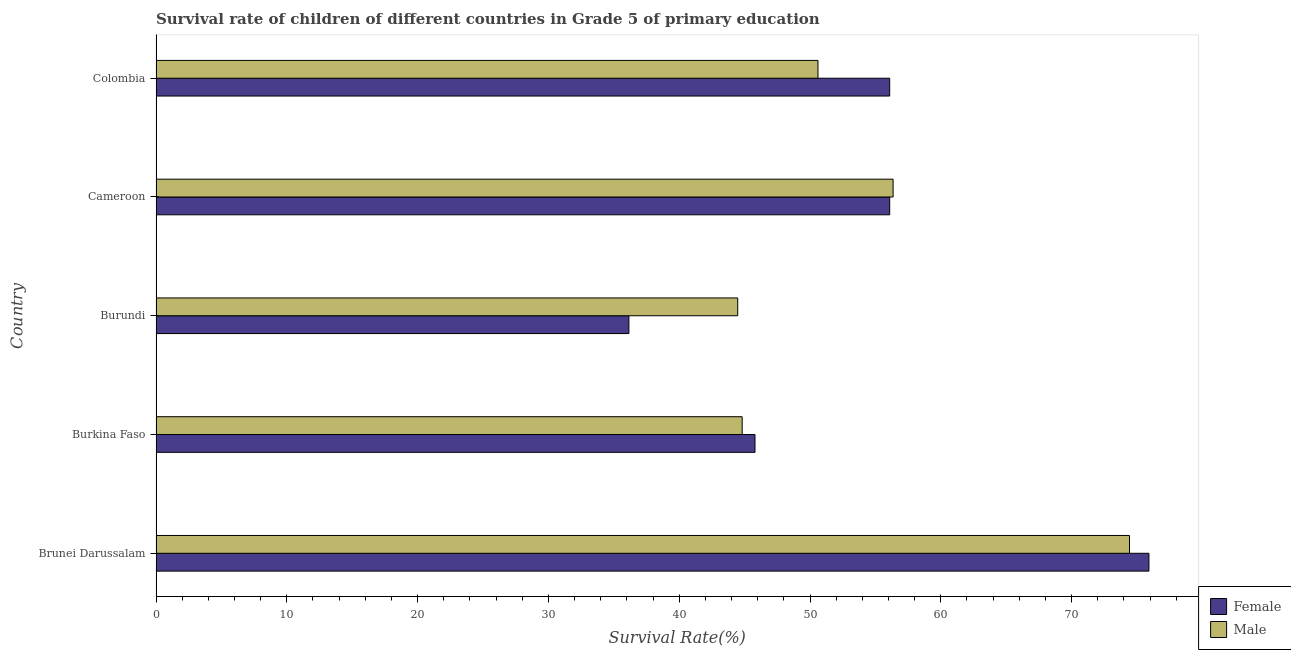Are the number of bars on each tick of the Y-axis equal?
Provide a succinct answer. Yes. What is the label of the 5th group of bars from the top?
Your response must be concise. Brunei Darussalam. What is the survival rate of male students in primary education in Brunei Darussalam?
Offer a very short reply. 74.42. Across all countries, what is the maximum survival rate of female students in primary education?
Give a very brief answer. 75.91. Across all countries, what is the minimum survival rate of female students in primary education?
Provide a short and direct response. 36.15. In which country was the survival rate of female students in primary education maximum?
Keep it short and to the point. Brunei Darussalam. In which country was the survival rate of male students in primary education minimum?
Your answer should be compact. Burundi. What is the total survival rate of female students in primary education in the graph?
Your response must be concise. 270.04. What is the difference between the survival rate of female students in primary education in Brunei Darussalam and that in Burkina Faso?
Make the answer very short. 30.12. What is the difference between the survival rate of male students in primary education in Burundi and the survival rate of female students in primary education in Burkina Faso?
Offer a terse response. -1.32. What is the average survival rate of male students in primary education per country?
Make the answer very short. 54.13. What is the difference between the survival rate of female students in primary education and survival rate of male students in primary education in Brunei Darussalam?
Offer a very short reply. 1.49. In how many countries, is the survival rate of female students in primary education greater than 30 %?
Keep it short and to the point. 5. What is the ratio of the survival rate of male students in primary education in Brunei Darussalam to that in Burkina Faso?
Provide a succinct answer. 1.66. Is the survival rate of female students in primary education in Brunei Darussalam less than that in Burundi?
Your response must be concise. No. Is the difference between the survival rate of male students in primary education in Brunei Darussalam and Cameroon greater than the difference between the survival rate of female students in primary education in Brunei Darussalam and Cameroon?
Ensure brevity in your answer.  No. What is the difference between the highest and the second highest survival rate of male students in primary education?
Give a very brief answer. 18.07. What is the difference between the highest and the lowest survival rate of male students in primary education?
Keep it short and to the point. 29.95. In how many countries, is the survival rate of female students in primary education greater than the average survival rate of female students in primary education taken over all countries?
Ensure brevity in your answer.  3. What does the 2nd bar from the top in Burkina Faso represents?
Ensure brevity in your answer.  Female. What does the 2nd bar from the bottom in Colombia represents?
Your answer should be very brief. Male. Are the values on the major ticks of X-axis written in scientific E-notation?
Offer a very short reply. No. What is the title of the graph?
Offer a terse response. Survival rate of children of different countries in Grade 5 of primary education. What is the label or title of the X-axis?
Keep it short and to the point. Survival Rate(%). What is the label or title of the Y-axis?
Provide a short and direct response. Country. What is the Survival Rate(%) of Female in Brunei Darussalam?
Make the answer very short. 75.91. What is the Survival Rate(%) in Male in Brunei Darussalam?
Provide a succinct answer. 74.42. What is the Survival Rate(%) in Female in Burkina Faso?
Give a very brief answer. 45.79. What is the Survival Rate(%) of Male in Burkina Faso?
Provide a short and direct response. 44.81. What is the Survival Rate(%) of Female in Burundi?
Offer a very short reply. 36.15. What is the Survival Rate(%) in Male in Burundi?
Keep it short and to the point. 44.47. What is the Survival Rate(%) in Female in Cameroon?
Provide a succinct answer. 56.09. What is the Survival Rate(%) in Male in Cameroon?
Your response must be concise. 56.35. What is the Survival Rate(%) in Female in Colombia?
Provide a short and direct response. 56.09. What is the Survival Rate(%) of Male in Colombia?
Keep it short and to the point. 50.61. Across all countries, what is the maximum Survival Rate(%) of Female?
Provide a short and direct response. 75.91. Across all countries, what is the maximum Survival Rate(%) in Male?
Provide a short and direct response. 74.42. Across all countries, what is the minimum Survival Rate(%) in Female?
Your answer should be compact. 36.15. Across all countries, what is the minimum Survival Rate(%) in Male?
Keep it short and to the point. 44.47. What is the total Survival Rate(%) in Female in the graph?
Ensure brevity in your answer.  270.04. What is the total Survival Rate(%) in Male in the graph?
Your answer should be compact. 270.67. What is the difference between the Survival Rate(%) of Female in Brunei Darussalam and that in Burkina Faso?
Offer a very short reply. 30.12. What is the difference between the Survival Rate(%) in Male in Brunei Darussalam and that in Burkina Faso?
Provide a short and direct response. 29.61. What is the difference between the Survival Rate(%) in Female in Brunei Darussalam and that in Burundi?
Offer a very short reply. 39.76. What is the difference between the Survival Rate(%) in Male in Brunei Darussalam and that in Burundi?
Ensure brevity in your answer.  29.95. What is the difference between the Survival Rate(%) in Female in Brunei Darussalam and that in Cameroon?
Your answer should be compact. 19.82. What is the difference between the Survival Rate(%) in Male in Brunei Darussalam and that in Cameroon?
Keep it short and to the point. 18.07. What is the difference between the Survival Rate(%) in Female in Brunei Darussalam and that in Colombia?
Offer a terse response. 19.82. What is the difference between the Survival Rate(%) in Male in Brunei Darussalam and that in Colombia?
Give a very brief answer. 23.82. What is the difference between the Survival Rate(%) in Female in Burkina Faso and that in Burundi?
Make the answer very short. 9.64. What is the difference between the Survival Rate(%) of Male in Burkina Faso and that in Burundi?
Keep it short and to the point. 0.34. What is the difference between the Survival Rate(%) of Female in Burkina Faso and that in Cameroon?
Your answer should be very brief. -10.3. What is the difference between the Survival Rate(%) of Male in Burkina Faso and that in Cameroon?
Your answer should be compact. -11.54. What is the difference between the Survival Rate(%) in Female in Burkina Faso and that in Colombia?
Your response must be concise. -10.3. What is the difference between the Survival Rate(%) of Male in Burkina Faso and that in Colombia?
Offer a terse response. -5.79. What is the difference between the Survival Rate(%) in Female in Burundi and that in Cameroon?
Provide a succinct answer. -19.94. What is the difference between the Survival Rate(%) of Male in Burundi and that in Cameroon?
Your answer should be very brief. -11.88. What is the difference between the Survival Rate(%) of Female in Burundi and that in Colombia?
Ensure brevity in your answer.  -19.94. What is the difference between the Survival Rate(%) in Male in Burundi and that in Colombia?
Make the answer very short. -6.14. What is the difference between the Survival Rate(%) of Female in Cameroon and that in Colombia?
Provide a short and direct response. 0. What is the difference between the Survival Rate(%) of Male in Cameroon and that in Colombia?
Provide a short and direct response. 5.74. What is the difference between the Survival Rate(%) of Female in Brunei Darussalam and the Survival Rate(%) of Male in Burkina Faso?
Your answer should be compact. 31.1. What is the difference between the Survival Rate(%) in Female in Brunei Darussalam and the Survival Rate(%) in Male in Burundi?
Offer a terse response. 31.44. What is the difference between the Survival Rate(%) of Female in Brunei Darussalam and the Survival Rate(%) of Male in Cameroon?
Your answer should be compact. 19.56. What is the difference between the Survival Rate(%) of Female in Brunei Darussalam and the Survival Rate(%) of Male in Colombia?
Make the answer very short. 25.3. What is the difference between the Survival Rate(%) of Female in Burkina Faso and the Survival Rate(%) of Male in Burundi?
Your answer should be compact. 1.32. What is the difference between the Survival Rate(%) of Female in Burkina Faso and the Survival Rate(%) of Male in Cameroon?
Offer a very short reply. -10.56. What is the difference between the Survival Rate(%) of Female in Burkina Faso and the Survival Rate(%) of Male in Colombia?
Give a very brief answer. -4.81. What is the difference between the Survival Rate(%) in Female in Burundi and the Survival Rate(%) in Male in Cameroon?
Give a very brief answer. -20.2. What is the difference between the Survival Rate(%) in Female in Burundi and the Survival Rate(%) in Male in Colombia?
Ensure brevity in your answer.  -14.45. What is the difference between the Survival Rate(%) in Female in Cameroon and the Survival Rate(%) in Male in Colombia?
Make the answer very short. 5.48. What is the average Survival Rate(%) of Female per country?
Keep it short and to the point. 54.01. What is the average Survival Rate(%) in Male per country?
Give a very brief answer. 54.13. What is the difference between the Survival Rate(%) in Female and Survival Rate(%) in Male in Brunei Darussalam?
Offer a very short reply. 1.49. What is the difference between the Survival Rate(%) of Female and Survival Rate(%) of Male in Burkina Faso?
Your response must be concise. 0.98. What is the difference between the Survival Rate(%) of Female and Survival Rate(%) of Male in Burundi?
Ensure brevity in your answer.  -8.32. What is the difference between the Survival Rate(%) in Female and Survival Rate(%) in Male in Cameroon?
Make the answer very short. -0.26. What is the difference between the Survival Rate(%) of Female and Survival Rate(%) of Male in Colombia?
Your answer should be compact. 5.48. What is the ratio of the Survival Rate(%) in Female in Brunei Darussalam to that in Burkina Faso?
Your answer should be compact. 1.66. What is the ratio of the Survival Rate(%) in Male in Brunei Darussalam to that in Burkina Faso?
Offer a terse response. 1.66. What is the ratio of the Survival Rate(%) in Female in Brunei Darussalam to that in Burundi?
Keep it short and to the point. 2.1. What is the ratio of the Survival Rate(%) of Male in Brunei Darussalam to that in Burundi?
Your response must be concise. 1.67. What is the ratio of the Survival Rate(%) in Female in Brunei Darussalam to that in Cameroon?
Make the answer very short. 1.35. What is the ratio of the Survival Rate(%) in Male in Brunei Darussalam to that in Cameroon?
Your answer should be very brief. 1.32. What is the ratio of the Survival Rate(%) of Female in Brunei Darussalam to that in Colombia?
Offer a terse response. 1.35. What is the ratio of the Survival Rate(%) in Male in Brunei Darussalam to that in Colombia?
Give a very brief answer. 1.47. What is the ratio of the Survival Rate(%) of Female in Burkina Faso to that in Burundi?
Offer a terse response. 1.27. What is the ratio of the Survival Rate(%) in Male in Burkina Faso to that in Burundi?
Your answer should be compact. 1.01. What is the ratio of the Survival Rate(%) of Female in Burkina Faso to that in Cameroon?
Keep it short and to the point. 0.82. What is the ratio of the Survival Rate(%) of Male in Burkina Faso to that in Cameroon?
Keep it short and to the point. 0.8. What is the ratio of the Survival Rate(%) of Female in Burkina Faso to that in Colombia?
Your answer should be very brief. 0.82. What is the ratio of the Survival Rate(%) of Male in Burkina Faso to that in Colombia?
Offer a very short reply. 0.89. What is the ratio of the Survival Rate(%) in Female in Burundi to that in Cameroon?
Your response must be concise. 0.64. What is the ratio of the Survival Rate(%) of Male in Burundi to that in Cameroon?
Your answer should be very brief. 0.79. What is the ratio of the Survival Rate(%) in Female in Burundi to that in Colombia?
Your response must be concise. 0.64. What is the ratio of the Survival Rate(%) in Male in Burundi to that in Colombia?
Provide a short and direct response. 0.88. What is the ratio of the Survival Rate(%) in Female in Cameroon to that in Colombia?
Keep it short and to the point. 1. What is the ratio of the Survival Rate(%) of Male in Cameroon to that in Colombia?
Give a very brief answer. 1.11. What is the difference between the highest and the second highest Survival Rate(%) in Female?
Make the answer very short. 19.82. What is the difference between the highest and the second highest Survival Rate(%) in Male?
Your answer should be compact. 18.07. What is the difference between the highest and the lowest Survival Rate(%) of Female?
Give a very brief answer. 39.76. What is the difference between the highest and the lowest Survival Rate(%) of Male?
Provide a short and direct response. 29.95. 